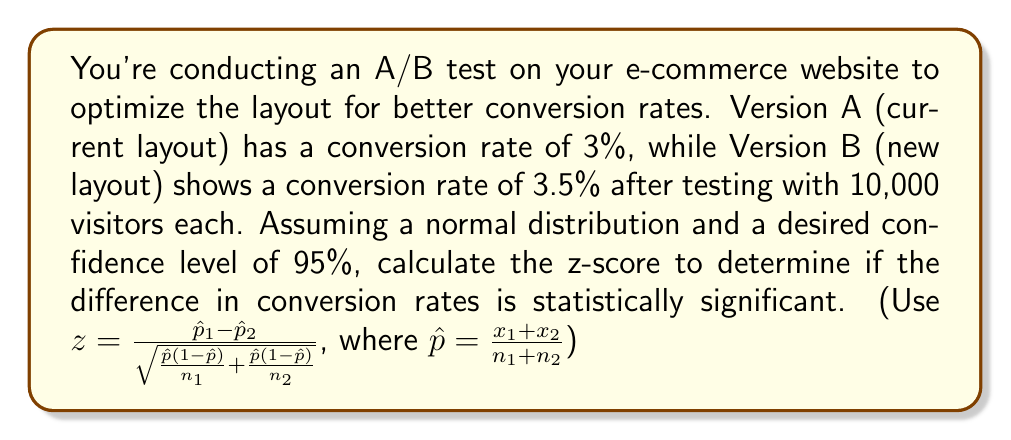Help me with this question. To determine if the difference in conversion rates is statistically significant, we need to calculate the z-score using the given formula. Let's break it down step by step:

1. Calculate $\hat{p}_1$ and $\hat{p}_2$:
   $\hat{p}_1 = 0.03$ (Version A)
   $\hat{p}_2 = 0.035$ (Version B)

2. Calculate $x_1$ and $x_2$ (number of conversions):
   $x_1 = 0.03 \times 10,000 = 300$
   $x_2 = 0.035 \times 10,000 = 350$

3. Calculate $\hat{p}$:
   $$\hat{p} = \frac{x_1 + x_2}{n_1 + n_2} = \frac{300 + 350}{10,000 + 10,000} = \frac{650}{20,000} = 0.0325$$

4. Calculate the denominator of the z-score formula:
   $$\sqrt{\frac{\hat{p}(1-\hat{p})}{n_1} + \frac{\hat{p}(1-\hat{p})}{n_2}}$$
   $$= \sqrt{\frac{0.0325(1-0.0325)}{10,000} + \frac{0.0325(1-0.0325)}{10,000}}$$
   $$= \sqrt{\frac{0.0325 \times 0.9675}{10,000} + \frac{0.0325 \times 0.9675}{10,000}}$$
   $$= \sqrt{2 \times \frac{0.0314437}{10,000}} = \sqrt{0.00000628874} = 0.00250774$$

5. Calculate the z-score:
   $$z = \frac{\hat{p}_1 - \hat{p}_2}{\sqrt{\frac{\hat{p}(1-\hat{p})}{n_1} + \frac{\hat{p}(1-\hat{p})}{n_2}}}$$
   $$= \frac{0.03 - 0.035}{0.00250774} = \frac{-0.005}{0.00250774} = -1.9938$$

6. The absolute value of the z-score is 1.9938, which is less than the critical value of 1.96 for a 95% confidence level.
Answer: -1.9938 